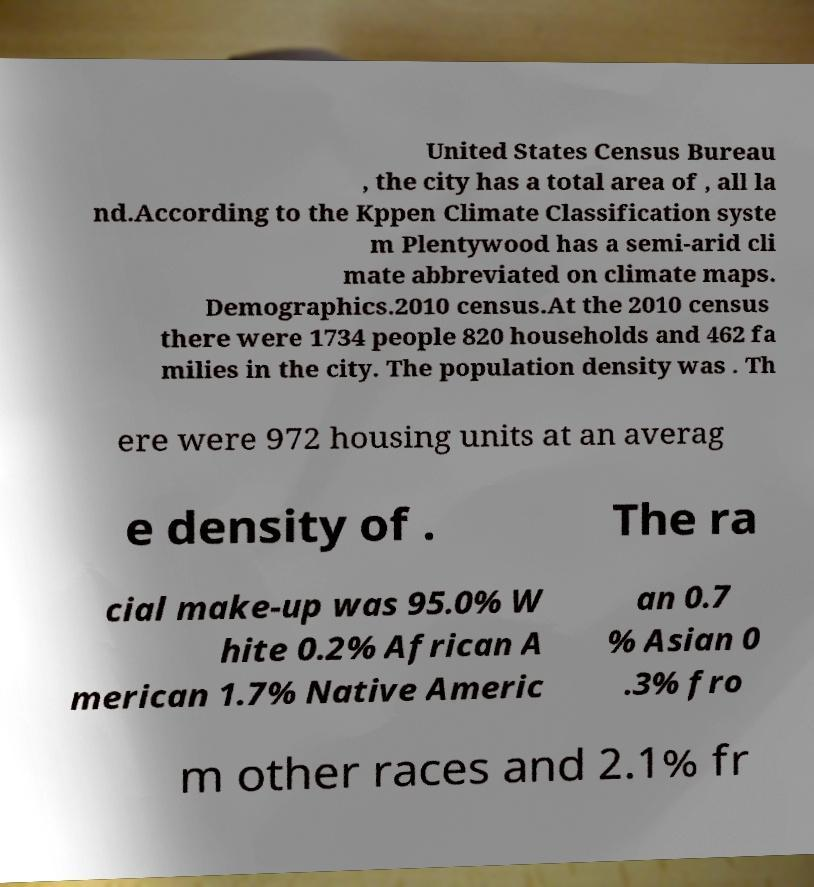Can you accurately transcribe the text from the provided image for me? United States Census Bureau , the city has a total area of , all la nd.According to the Kppen Climate Classification syste m Plentywood has a semi-arid cli mate abbreviated on climate maps. Demographics.2010 census.At the 2010 census there were 1734 people 820 households and 462 fa milies in the city. The population density was . Th ere were 972 housing units at an averag e density of . The ra cial make-up was 95.0% W hite 0.2% African A merican 1.7% Native Americ an 0.7 % Asian 0 .3% fro m other races and 2.1% fr 